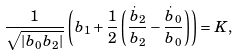Convert formula to latex. <formula><loc_0><loc_0><loc_500><loc_500>\frac { 1 } { \sqrt { | b _ { 0 } b _ { 2 } | } } \left ( b _ { 1 } + \frac { 1 } { 2 } \left ( \frac { \dot { b } _ { 2 } } { b _ { 2 } } - \frac { \dot { b } _ { 0 } } { b _ { 0 } } \right ) \right ) = K ,</formula> 